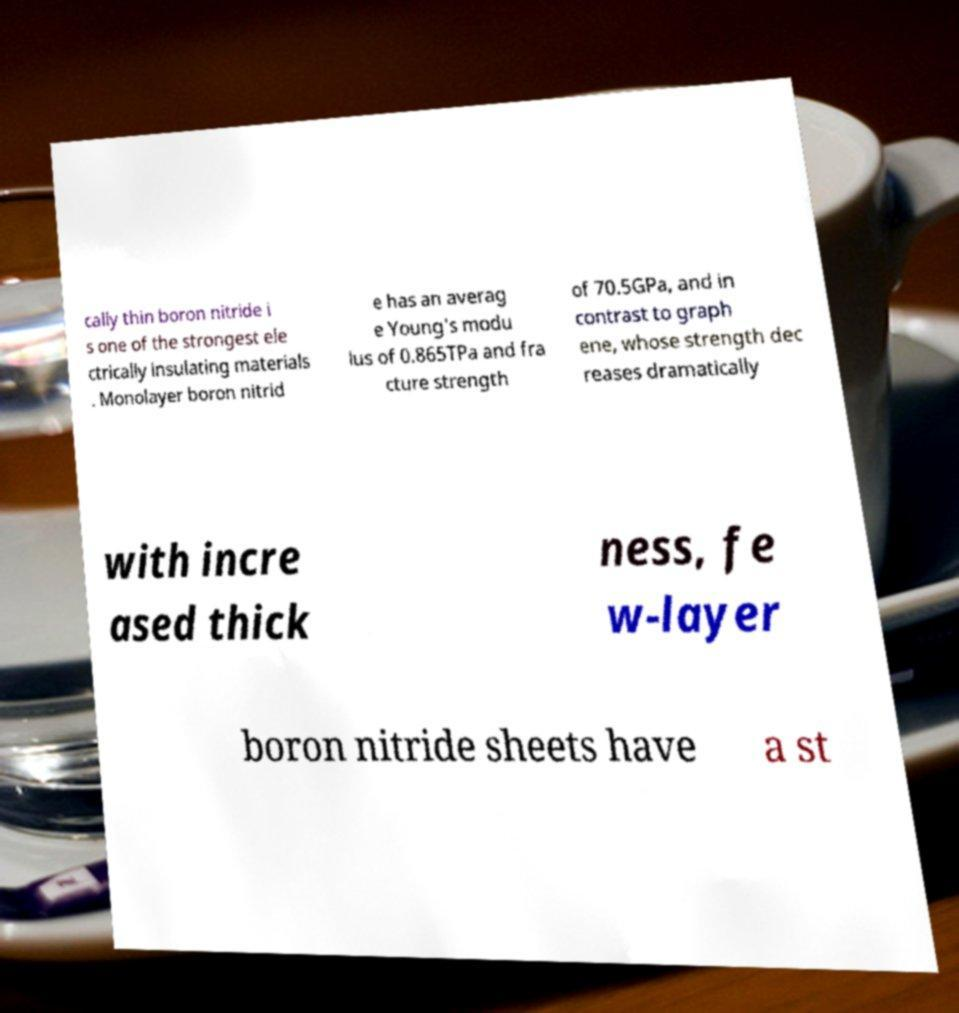Please read and relay the text visible in this image. What does it say? cally thin boron nitride i s one of the strongest ele ctrically insulating materials . Monolayer boron nitrid e has an averag e Young's modu lus of 0.865TPa and fra cture strength of 70.5GPa, and in contrast to graph ene, whose strength dec reases dramatically with incre ased thick ness, fe w-layer boron nitride sheets have a st 